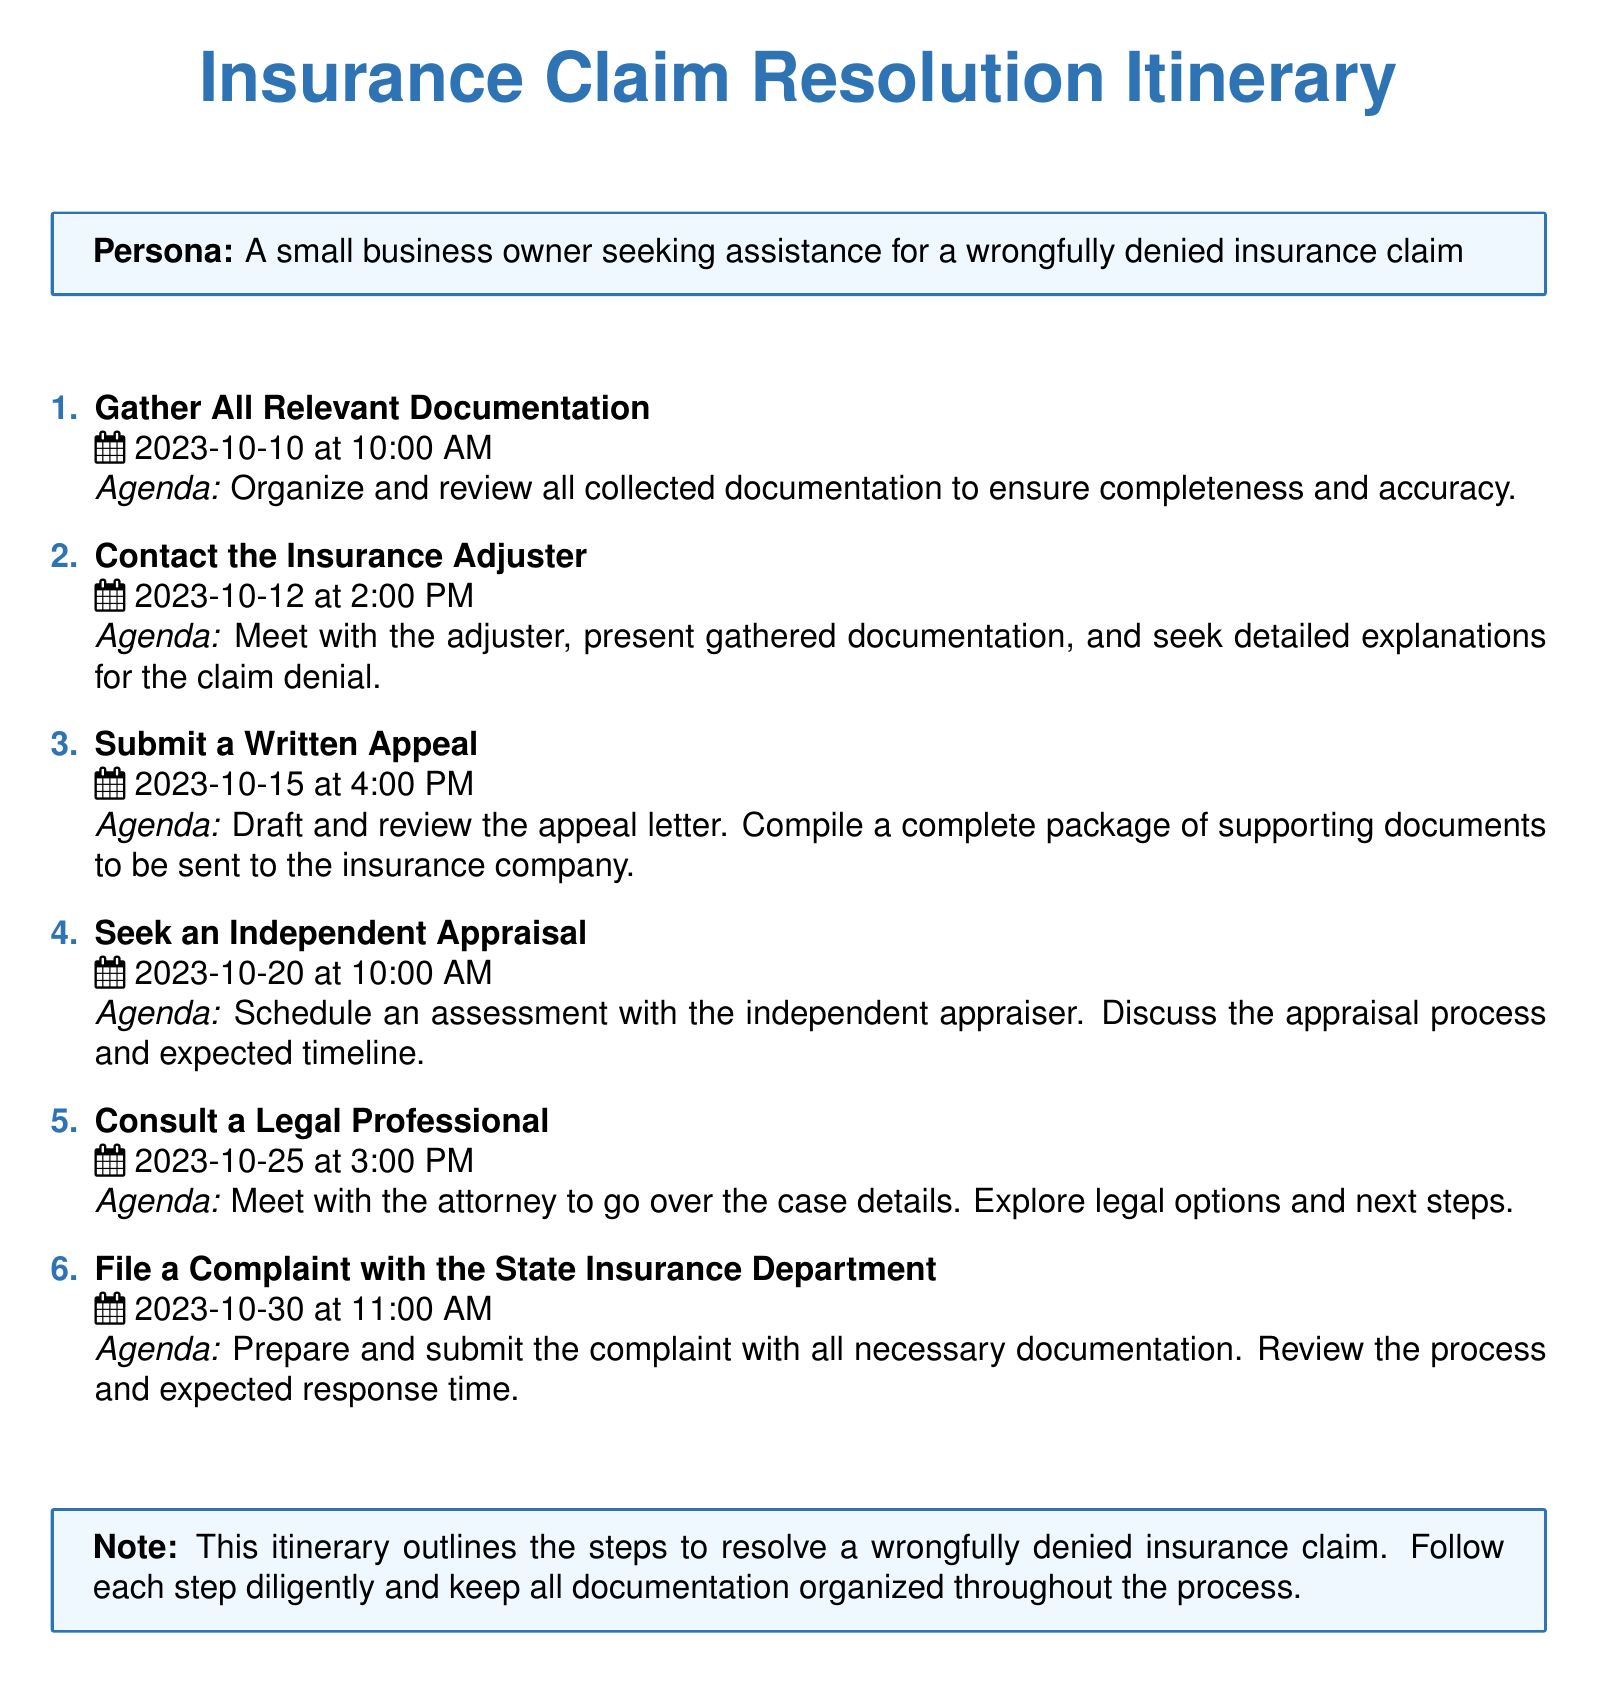What is the first step to resolve a wrongfully denied insurance claim? The first step outlined in the itinerary is to gather all relevant documentation.
Answer: Gather All Relevant Documentation When is the appointment to contact the insurance adjuster? The appointment to contact the insurance adjuster is scheduled for October 12, 2023, at 2:00 PM.
Answer: October 12, 2023, at 2:00 PM What is the agenda for submitting a written appeal? The agenda for submitting a written appeal includes drafting and reviewing the appeal letter and compiling supporting documents.
Answer: Draft and review the appeal letter What is the last step mentioned in the itinerary? The last step mentioned in the itinerary is to file a complaint with the State Insurance Department.
Answer: File a Complaint with the State Insurance Department What is the date and time for consulting a legal professional? The consultation with a legal professional is scheduled for October 25, 2023, at 3:00 PM.
Answer: October 25, 2023, at 3:00 PM How many total steps are outlined in the itinerary? There are a total of five steps outlined in the itinerary.
Answer: Five steps What should you do before the meeting with the insurance adjuster? Before the meeting, you should organize and review all collected documentation.
Answer: Organize and review all collected documentation What is the expected outcome of seeking an independent appraisal? The expected outcome is to get an assessment from an independent appraiser regarding the claim.
Answer: Assessment from an independent appraiser 